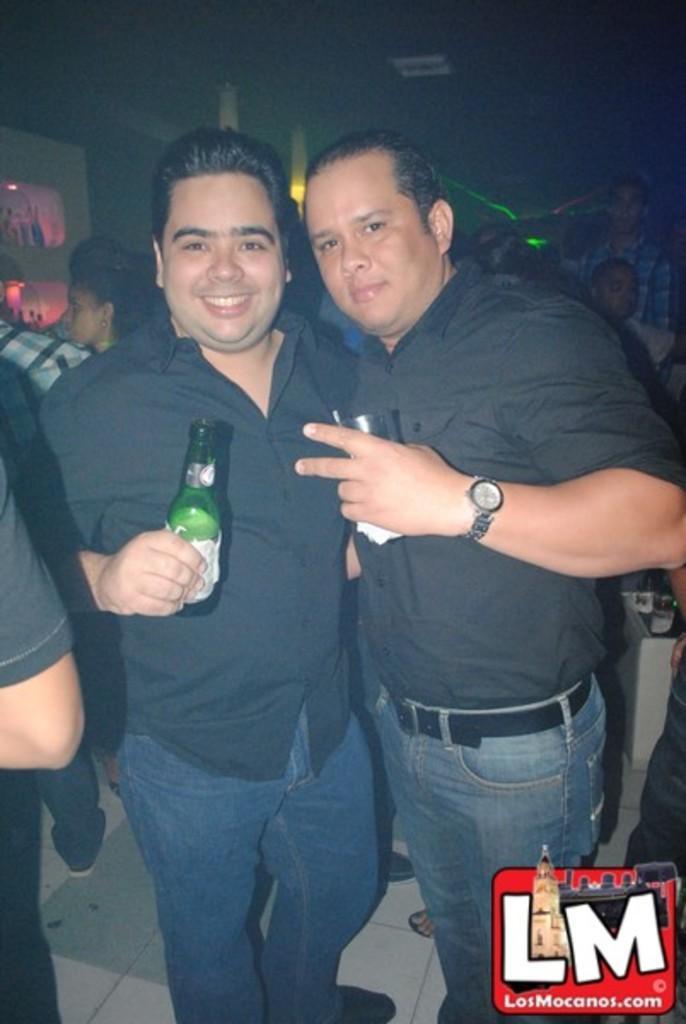Describe this image in one or two sentences. In the image we can see there are two men who are standing in front and a man is holding a wine bottle in his hand. 